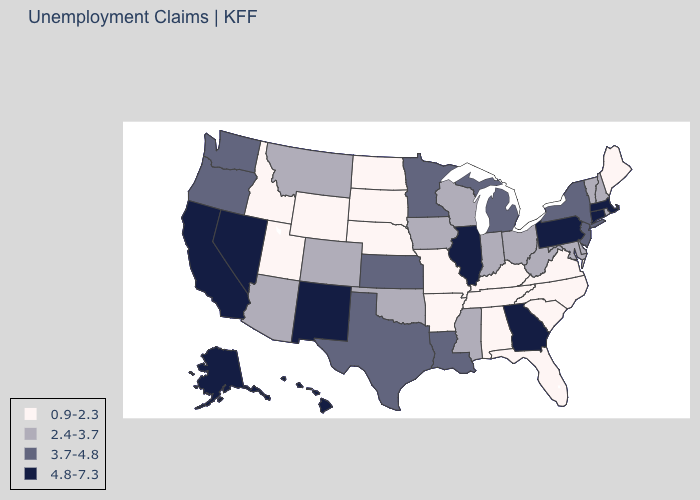Does Oregon have the same value as Utah?
Give a very brief answer. No. What is the lowest value in states that border Rhode Island?
Quick response, please. 4.8-7.3. How many symbols are there in the legend?
Concise answer only. 4. Name the states that have a value in the range 0.9-2.3?
Concise answer only. Alabama, Arkansas, Florida, Idaho, Kentucky, Maine, Missouri, Nebraska, North Carolina, North Dakota, South Carolina, South Dakota, Tennessee, Utah, Virginia, Wyoming. Does Kentucky have the highest value in the South?
Short answer required. No. Does Connecticut have a higher value than Texas?
Concise answer only. Yes. Name the states that have a value in the range 0.9-2.3?
Quick response, please. Alabama, Arkansas, Florida, Idaho, Kentucky, Maine, Missouri, Nebraska, North Carolina, North Dakota, South Carolina, South Dakota, Tennessee, Utah, Virginia, Wyoming. Does the first symbol in the legend represent the smallest category?
Give a very brief answer. Yes. Among the states that border Maine , which have the highest value?
Give a very brief answer. New Hampshire. Name the states that have a value in the range 4.8-7.3?
Answer briefly. Alaska, California, Connecticut, Georgia, Hawaii, Illinois, Massachusetts, Nevada, New Mexico, Pennsylvania. What is the highest value in the USA?
Write a very short answer. 4.8-7.3. What is the lowest value in the USA?
Concise answer only. 0.9-2.3. Name the states that have a value in the range 3.7-4.8?
Be succinct. Kansas, Louisiana, Michigan, Minnesota, New Jersey, New York, Oregon, Texas, Washington. What is the value of Nevada?
Keep it brief. 4.8-7.3. Does Alabama have the highest value in the South?
Be succinct. No. 